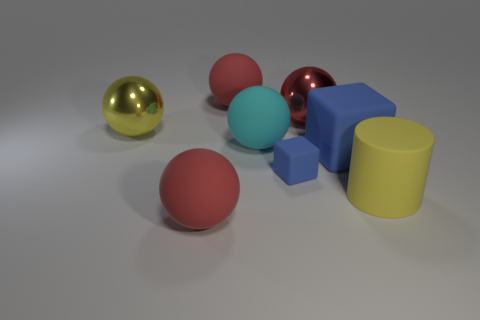Subtract all matte spheres. How many spheres are left? 2 Subtract all red spheres. How many spheres are left? 2 Add 2 large red matte balls. How many objects exist? 10 Subtract all cylinders. How many objects are left? 7 Subtract 2 spheres. How many spheres are left? 3 Add 7 small blue matte cubes. How many small blue matte cubes are left? 8 Add 7 shiny objects. How many shiny objects exist? 9 Subtract 0 cyan cubes. How many objects are left? 8 Subtract all blue balls. Subtract all blue cubes. How many balls are left? 5 Subtract all gray cylinders. How many cyan spheres are left? 1 